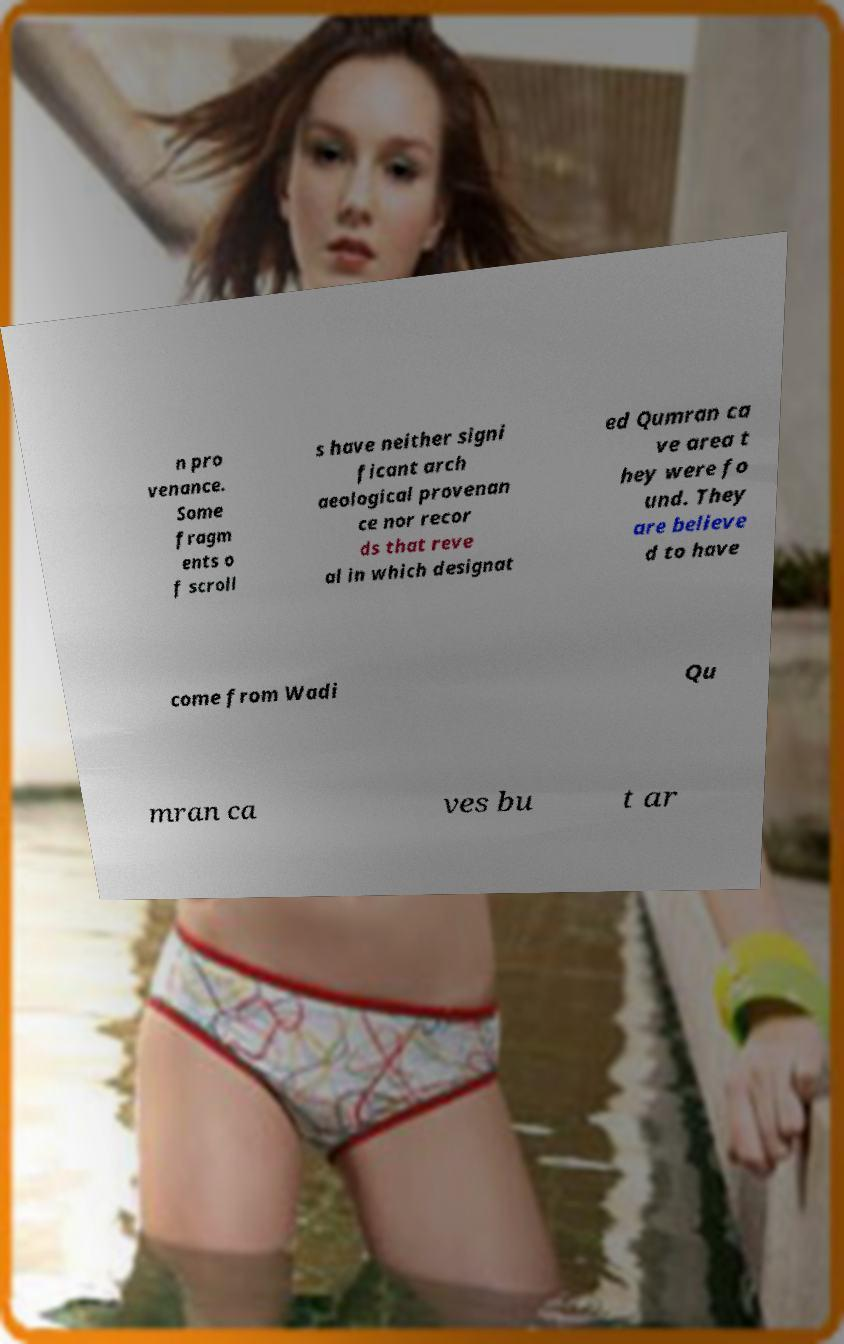There's text embedded in this image that I need extracted. Can you transcribe it verbatim? n pro venance. Some fragm ents o f scroll s have neither signi ficant arch aeological provenan ce nor recor ds that reve al in which designat ed Qumran ca ve area t hey were fo und. They are believe d to have come from Wadi Qu mran ca ves bu t ar 